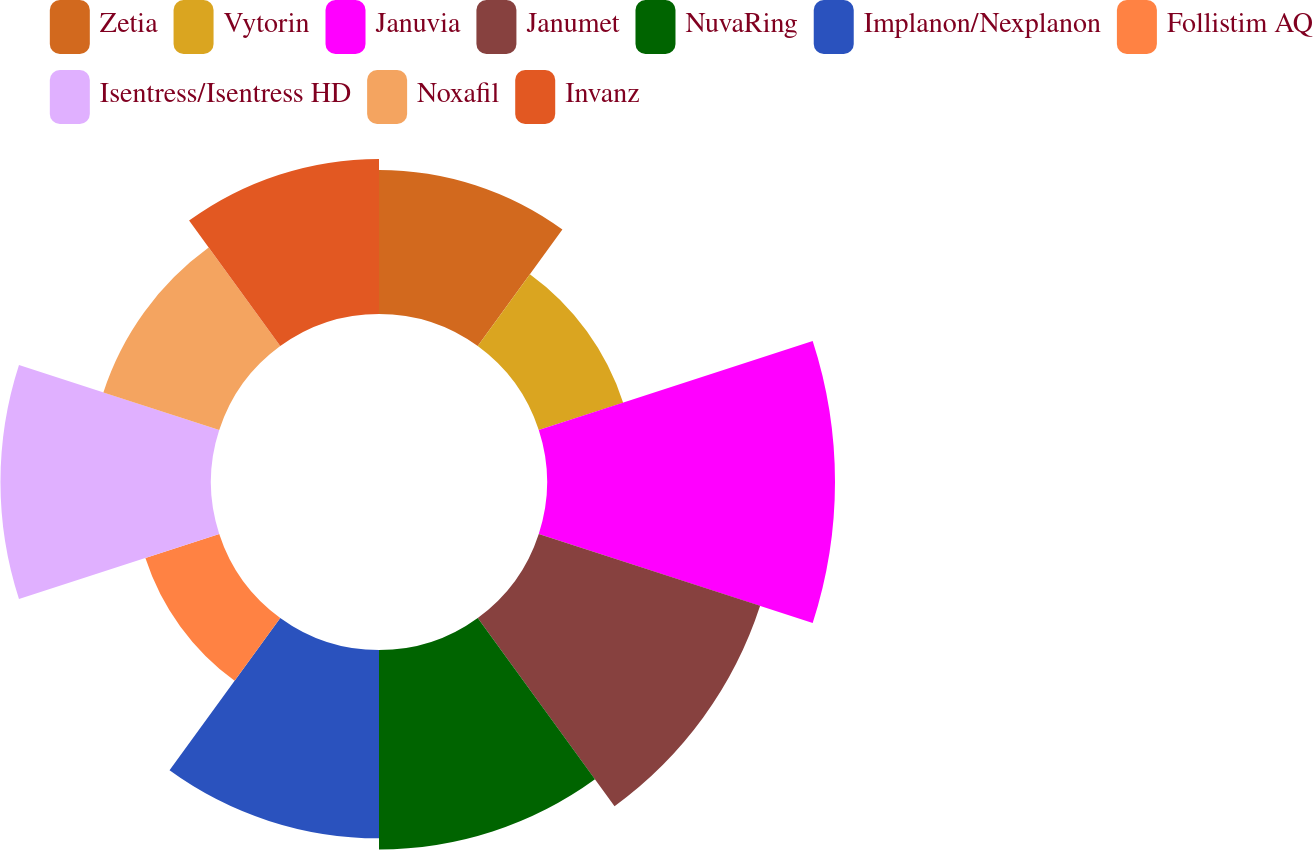<chart> <loc_0><loc_0><loc_500><loc_500><pie_chart><fcel>Zetia<fcel>Vytorin<fcel>Januvia<fcel>Janumet<fcel>NuvaRing<fcel>Implanon/Nexplanon<fcel>Follistim AQ<fcel>Isentress/Isentress HD<fcel>Noxafil<fcel>Invanz<nl><fcel>8.44%<fcel>5.2%<fcel>16.88%<fcel>13.64%<fcel>11.69%<fcel>11.04%<fcel>4.55%<fcel>12.34%<fcel>7.14%<fcel>9.09%<nl></chart> 